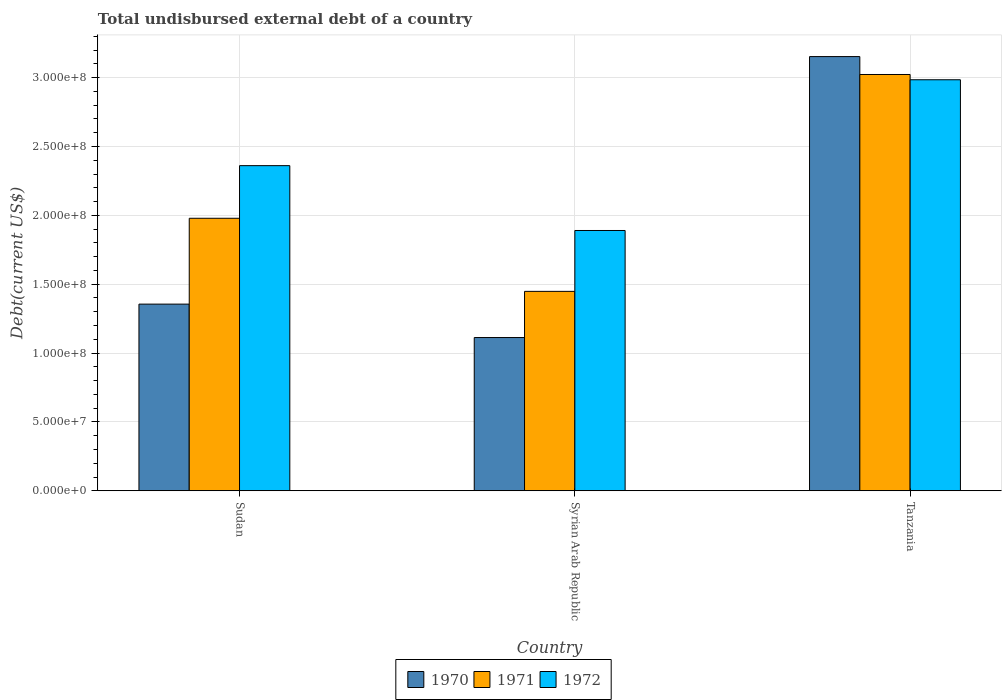How many groups of bars are there?
Your response must be concise. 3. Are the number of bars per tick equal to the number of legend labels?
Ensure brevity in your answer.  Yes. How many bars are there on the 2nd tick from the left?
Keep it short and to the point. 3. What is the label of the 1st group of bars from the left?
Give a very brief answer. Sudan. In how many cases, is the number of bars for a given country not equal to the number of legend labels?
Offer a very short reply. 0. What is the total undisbursed external debt in 1971 in Tanzania?
Provide a short and direct response. 3.02e+08. Across all countries, what is the maximum total undisbursed external debt in 1970?
Provide a short and direct response. 3.15e+08. Across all countries, what is the minimum total undisbursed external debt in 1972?
Your response must be concise. 1.89e+08. In which country was the total undisbursed external debt in 1971 maximum?
Your answer should be compact. Tanzania. In which country was the total undisbursed external debt in 1970 minimum?
Provide a short and direct response. Syrian Arab Republic. What is the total total undisbursed external debt in 1970 in the graph?
Give a very brief answer. 5.62e+08. What is the difference between the total undisbursed external debt in 1970 in Sudan and that in Tanzania?
Give a very brief answer. -1.80e+08. What is the difference between the total undisbursed external debt in 1970 in Sudan and the total undisbursed external debt in 1972 in Syrian Arab Republic?
Keep it short and to the point. -5.35e+07. What is the average total undisbursed external debt in 1972 per country?
Your answer should be very brief. 2.41e+08. What is the difference between the total undisbursed external debt of/in 1970 and total undisbursed external debt of/in 1971 in Sudan?
Your answer should be compact. -6.23e+07. What is the ratio of the total undisbursed external debt in 1970 in Syrian Arab Republic to that in Tanzania?
Your answer should be compact. 0.35. What is the difference between the highest and the second highest total undisbursed external debt in 1970?
Provide a short and direct response. 2.04e+08. What is the difference between the highest and the lowest total undisbursed external debt in 1971?
Make the answer very short. 1.57e+08. In how many countries, is the total undisbursed external debt in 1970 greater than the average total undisbursed external debt in 1970 taken over all countries?
Your answer should be compact. 1. Is the sum of the total undisbursed external debt in 1971 in Syrian Arab Republic and Tanzania greater than the maximum total undisbursed external debt in 1972 across all countries?
Offer a terse response. Yes. Is it the case that in every country, the sum of the total undisbursed external debt in 1971 and total undisbursed external debt in 1972 is greater than the total undisbursed external debt in 1970?
Make the answer very short. Yes. How many bars are there?
Provide a succinct answer. 9. Are all the bars in the graph horizontal?
Keep it short and to the point. No. How many countries are there in the graph?
Your response must be concise. 3. Does the graph contain any zero values?
Your response must be concise. No. Where does the legend appear in the graph?
Offer a very short reply. Bottom center. How many legend labels are there?
Ensure brevity in your answer.  3. What is the title of the graph?
Make the answer very short. Total undisbursed external debt of a country. Does "1990" appear as one of the legend labels in the graph?
Make the answer very short. No. What is the label or title of the Y-axis?
Provide a succinct answer. Debt(current US$). What is the Debt(current US$) of 1970 in Sudan?
Your answer should be very brief. 1.36e+08. What is the Debt(current US$) of 1971 in Sudan?
Your answer should be very brief. 1.98e+08. What is the Debt(current US$) of 1972 in Sudan?
Offer a terse response. 2.36e+08. What is the Debt(current US$) of 1970 in Syrian Arab Republic?
Your answer should be compact. 1.11e+08. What is the Debt(current US$) of 1971 in Syrian Arab Republic?
Make the answer very short. 1.45e+08. What is the Debt(current US$) of 1972 in Syrian Arab Republic?
Offer a very short reply. 1.89e+08. What is the Debt(current US$) in 1970 in Tanzania?
Offer a very short reply. 3.15e+08. What is the Debt(current US$) of 1971 in Tanzania?
Your response must be concise. 3.02e+08. What is the Debt(current US$) in 1972 in Tanzania?
Your answer should be very brief. 2.98e+08. Across all countries, what is the maximum Debt(current US$) in 1970?
Your response must be concise. 3.15e+08. Across all countries, what is the maximum Debt(current US$) in 1971?
Give a very brief answer. 3.02e+08. Across all countries, what is the maximum Debt(current US$) in 1972?
Offer a terse response. 2.98e+08. Across all countries, what is the minimum Debt(current US$) in 1970?
Ensure brevity in your answer.  1.11e+08. Across all countries, what is the minimum Debt(current US$) of 1971?
Your answer should be compact. 1.45e+08. Across all countries, what is the minimum Debt(current US$) of 1972?
Make the answer very short. 1.89e+08. What is the total Debt(current US$) of 1970 in the graph?
Offer a very short reply. 5.62e+08. What is the total Debt(current US$) of 1971 in the graph?
Make the answer very short. 6.45e+08. What is the total Debt(current US$) of 1972 in the graph?
Make the answer very short. 7.24e+08. What is the difference between the Debt(current US$) of 1970 in Sudan and that in Syrian Arab Republic?
Give a very brief answer. 2.43e+07. What is the difference between the Debt(current US$) of 1971 in Sudan and that in Syrian Arab Republic?
Make the answer very short. 5.31e+07. What is the difference between the Debt(current US$) of 1972 in Sudan and that in Syrian Arab Republic?
Your answer should be very brief. 4.71e+07. What is the difference between the Debt(current US$) in 1970 in Sudan and that in Tanzania?
Offer a terse response. -1.80e+08. What is the difference between the Debt(current US$) in 1971 in Sudan and that in Tanzania?
Offer a very short reply. -1.04e+08. What is the difference between the Debt(current US$) in 1972 in Sudan and that in Tanzania?
Keep it short and to the point. -6.24e+07. What is the difference between the Debt(current US$) of 1970 in Syrian Arab Republic and that in Tanzania?
Give a very brief answer. -2.04e+08. What is the difference between the Debt(current US$) in 1971 in Syrian Arab Republic and that in Tanzania?
Provide a succinct answer. -1.57e+08. What is the difference between the Debt(current US$) of 1972 in Syrian Arab Republic and that in Tanzania?
Provide a short and direct response. -1.09e+08. What is the difference between the Debt(current US$) in 1970 in Sudan and the Debt(current US$) in 1971 in Syrian Arab Republic?
Give a very brief answer. -9.26e+06. What is the difference between the Debt(current US$) of 1970 in Sudan and the Debt(current US$) of 1972 in Syrian Arab Republic?
Offer a very short reply. -5.35e+07. What is the difference between the Debt(current US$) of 1971 in Sudan and the Debt(current US$) of 1972 in Syrian Arab Republic?
Your answer should be compact. 8.87e+06. What is the difference between the Debt(current US$) of 1970 in Sudan and the Debt(current US$) of 1971 in Tanzania?
Offer a terse response. -1.67e+08. What is the difference between the Debt(current US$) in 1970 in Sudan and the Debt(current US$) in 1972 in Tanzania?
Make the answer very short. -1.63e+08. What is the difference between the Debt(current US$) of 1971 in Sudan and the Debt(current US$) of 1972 in Tanzania?
Keep it short and to the point. -1.01e+08. What is the difference between the Debt(current US$) of 1970 in Syrian Arab Republic and the Debt(current US$) of 1971 in Tanzania?
Your response must be concise. -1.91e+08. What is the difference between the Debt(current US$) in 1970 in Syrian Arab Republic and the Debt(current US$) in 1972 in Tanzania?
Offer a very short reply. -1.87e+08. What is the difference between the Debt(current US$) of 1971 in Syrian Arab Republic and the Debt(current US$) of 1972 in Tanzania?
Offer a very short reply. -1.54e+08. What is the average Debt(current US$) of 1970 per country?
Ensure brevity in your answer.  1.87e+08. What is the average Debt(current US$) of 1971 per country?
Ensure brevity in your answer.  2.15e+08. What is the average Debt(current US$) of 1972 per country?
Your response must be concise. 2.41e+08. What is the difference between the Debt(current US$) of 1970 and Debt(current US$) of 1971 in Sudan?
Provide a short and direct response. -6.23e+07. What is the difference between the Debt(current US$) of 1970 and Debt(current US$) of 1972 in Sudan?
Your answer should be very brief. -1.01e+08. What is the difference between the Debt(current US$) of 1971 and Debt(current US$) of 1972 in Sudan?
Give a very brief answer. -3.82e+07. What is the difference between the Debt(current US$) of 1970 and Debt(current US$) of 1971 in Syrian Arab Republic?
Your answer should be very brief. -3.35e+07. What is the difference between the Debt(current US$) of 1970 and Debt(current US$) of 1972 in Syrian Arab Republic?
Keep it short and to the point. -7.77e+07. What is the difference between the Debt(current US$) in 1971 and Debt(current US$) in 1972 in Syrian Arab Republic?
Provide a short and direct response. -4.42e+07. What is the difference between the Debt(current US$) of 1970 and Debt(current US$) of 1971 in Tanzania?
Your answer should be very brief. 1.30e+07. What is the difference between the Debt(current US$) in 1970 and Debt(current US$) in 1972 in Tanzania?
Your response must be concise. 1.68e+07. What is the difference between the Debt(current US$) of 1971 and Debt(current US$) of 1972 in Tanzania?
Make the answer very short. 3.82e+06. What is the ratio of the Debt(current US$) of 1970 in Sudan to that in Syrian Arab Republic?
Provide a short and direct response. 1.22. What is the ratio of the Debt(current US$) of 1971 in Sudan to that in Syrian Arab Republic?
Your answer should be very brief. 1.37. What is the ratio of the Debt(current US$) of 1972 in Sudan to that in Syrian Arab Republic?
Your answer should be compact. 1.25. What is the ratio of the Debt(current US$) of 1970 in Sudan to that in Tanzania?
Offer a terse response. 0.43. What is the ratio of the Debt(current US$) in 1971 in Sudan to that in Tanzania?
Ensure brevity in your answer.  0.65. What is the ratio of the Debt(current US$) of 1972 in Sudan to that in Tanzania?
Your answer should be compact. 0.79. What is the ratio of the Debt(current US$) of 1970 in Syrian Arab Republic to that in Tanzania?
Ensure brevity in your answer.  0.35. What is the ratio of the Debt(current US$) in 1971 in Syrian Arab Republic to that in Tanzania?
Ensure brevity in your answer.  0.48. What is the ratio of the Debt(current US$) in 1972 in Syrian Arab Republic to that in Tanzania?
Make the answer very short. 0.63. What is the difference between the highest and the second highest Debt(current US$) of 1970?
Make the answer very short. 1.80e+08. What is the difference between the highest and the second highest Debt(current US$) of 1971?
Offer a very short reply. 1.04e+08. What is the difference between the highest and the second highest Debt(current US$) in 1972?
Offer a terse response. 6.24e+07. What is the difference between the highest and the lowest Debt(current US$) in 1970?
Your answer should be compact. 2.04e+08. What is the difference between the highest and the lowest Debt(current US$) in 1971?
Your response must be concise. 1.57e+08. What is the difference between the highest and the lowest Debt(current US$) in 1972?
Ensure brevity in your answer.  1.09e+08. 